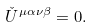<formula> <loc_0><loc_0><loc_500><loc_500>\check { U } ^ { \mu \alpha \nu \beta } = 0 .</formula> 